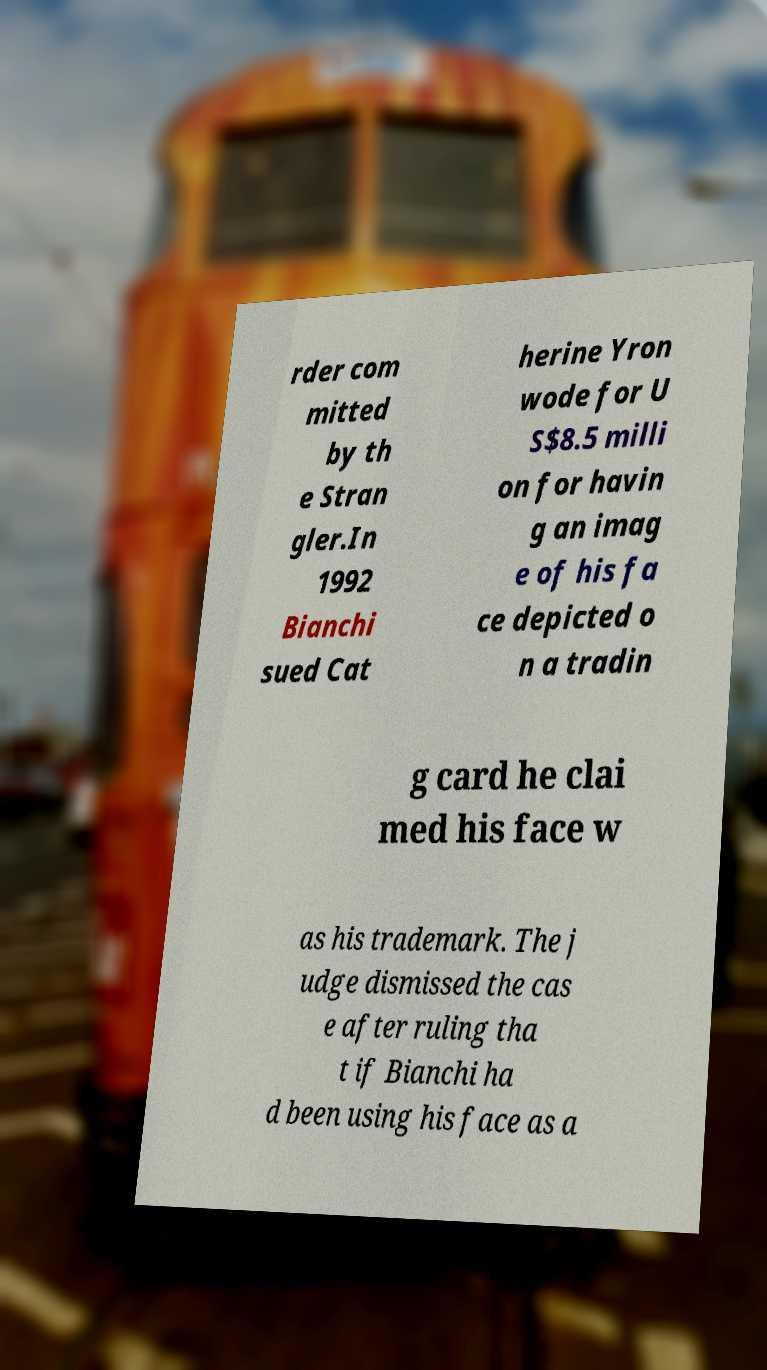Could you extract and type out the text from this image? rder com mitted by th e Stran gler.In 1992 Bianchi sued Cat herine Yron wode for U S$8.5 milli on for havin g an imag e of his fa ce depicted o n a tradin g card he clai med his face w as his trademark. The j udge dismissed the cas e after ruling tha t if Bianchi ha d been using his face as a 